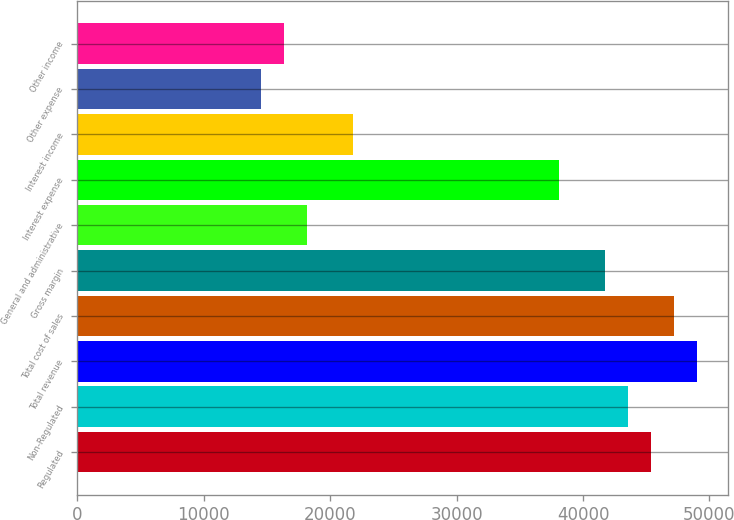Convert chart to OTSL. <chart><loc_0><loc_0><loc_500><loc_500><bar_chart><fcel>Regulated<fcel>Non-Regulated<fcel>Total revenue<fcel>Total cost of sales<fcel>Gross margin<fcel>General and administrative<fcel>Interest expense<fcel>Interest income<fcel>Other expense<fcel>Other income<nl><fcel>45350.7<fcel>43536.7<fcel>48978.7<fcel>47164.7<fcel>41722.8<fcel>18141<fcel>38094.8<fcel>21769<fcel>14513<fcel>16327<nl></chart> 